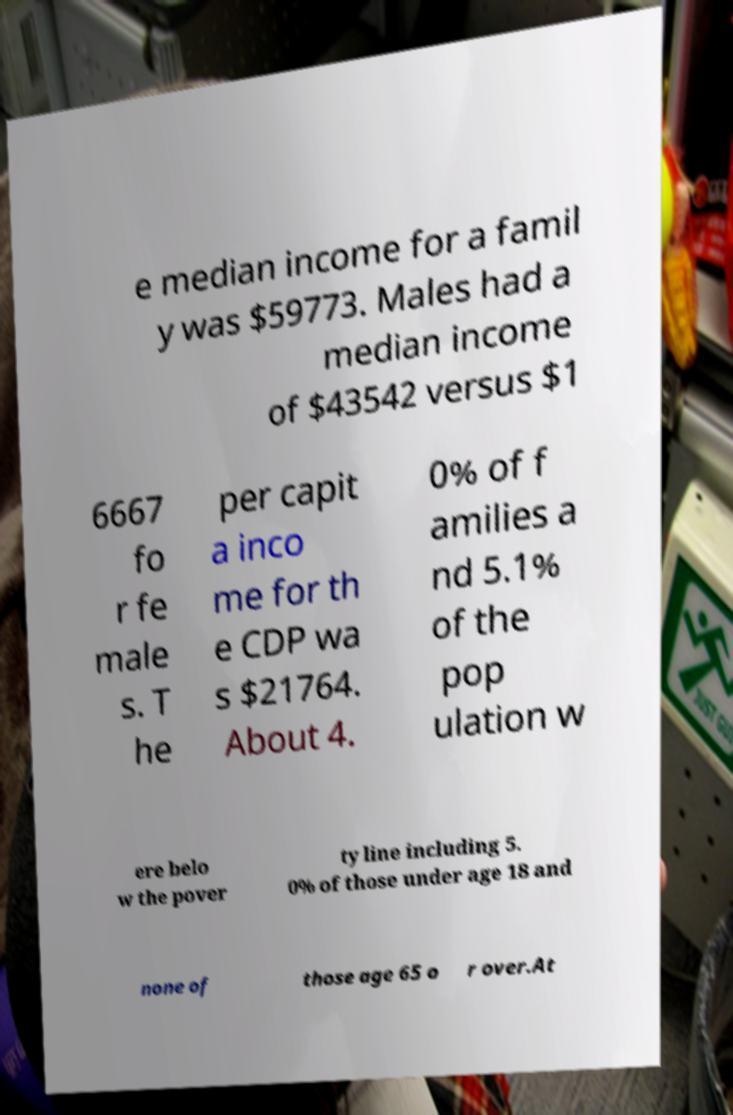There's text embedded in this image that I need extracted. Can you transcribe it verbatim? e median income for a famil y was $59773. Males had a median income of $43542 versus $1 6667 fo r fe male s. T he per capit a inco me for th e CDP wa s $21764. About 4. 0% of f amilies a nd 5.1% of the pop ulation w ere belo w the pover ty line including 5. 0% of those under age 18 and none of those age 65 o r over.At 